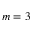<formula> <loc_0><loc_0><loc_500><loc_500>m = 3</formula> 